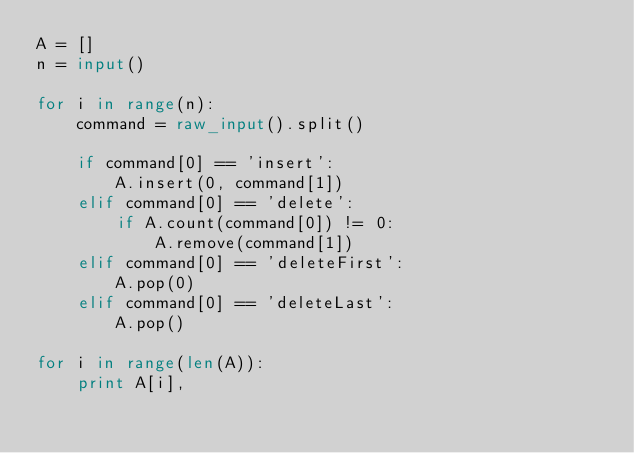Convert code to text. <code><loc_0><loc_0><loc_500><loc_500><_Python_>A = []
n = input()

for i in range(n):
    command = raw_input().split()

    if command[0] == 'insert':
        A.insert(0, command[1])
    elif command[0] == 'delete':
        if A.count(command[0]) != 0:
            A.remove(command[1])
    elif command[0] == 'deleteFirst':
        A.pop(0)
    elif command[0] == 'deleteLast':
        A.pop()

for i in range(len(A)):
    print A[i],</code> 